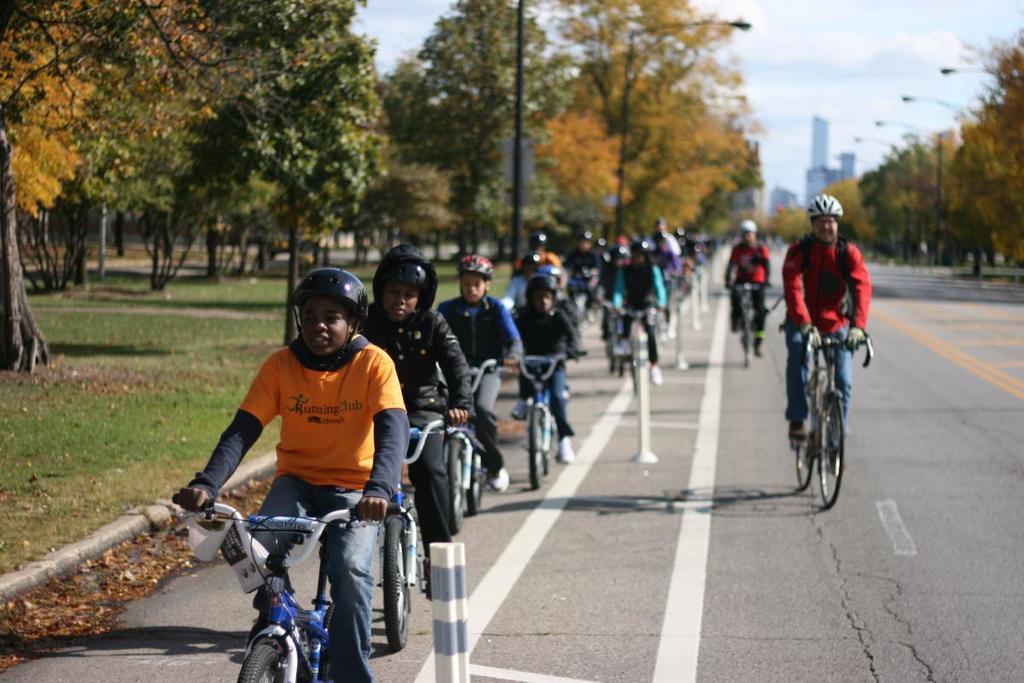Describe this image in one or two sentences. people are riding bicycle on the road. they are wearing helmets. to their left and right there are trees. at the back there are buildings. 